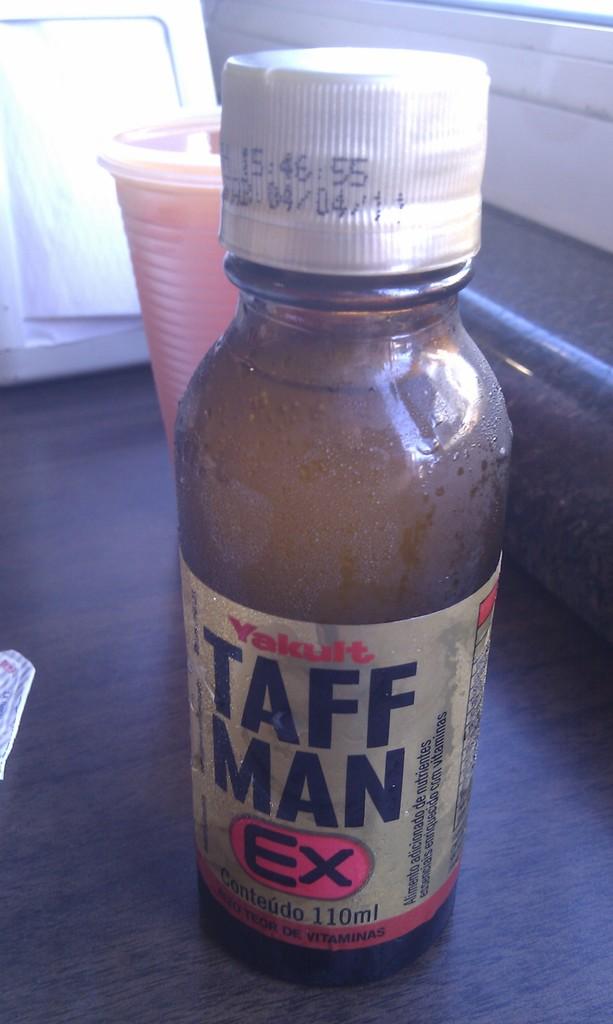How many ml is in this bottle?
Make the answer very short. 110. 